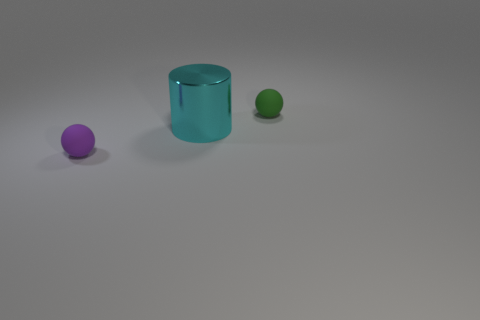There is a small rubber ball that is on the right side of the cyan metal cylinder; how many small balls are in front of it?
Offer a terse response. 1. What number of objects are either balls that are left of the green thing or small purple cylinders?
Your response must be concise. 1. Is there a green rubber object of the same shape as the purple matte thing?
Make the answer very short. Yes. What shape is the big cyan shiny object to the left of the tiny matte sphere that is behind the cyan object?
Offer a very short reply. Cylinder. How many blocks are tiny green metal things or small things?
Ensure brevity in your answer.  0. Does the tiny rubber thing that is left of the cyan cylinder have the same shape as the tiny thing that is behind the small purple rubber object?
Ensure brevity in your answer.  Yes. What is the color of the thing that is to the left of the small green thing and to the right of the small purple sphere?
Your response must be concise. Cyan. There is a thing that is both on the left side of the small green matte sphere and behind the small purple matte sphere; what size is it?
Keep it short and to the point. Large. How many other things are there of the same color as the large metallic thing?
Provide a short and direct response. 0. There is a green thing that is behind the matte thing that is in front of the rubber sphere to the right of the cylinder; what size is it?
Your answer should be very brief. Small. 